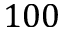Convert formula to latex. <formula><loc_0><loc_0><loc_500><loc_500>1 0 0</formula> 